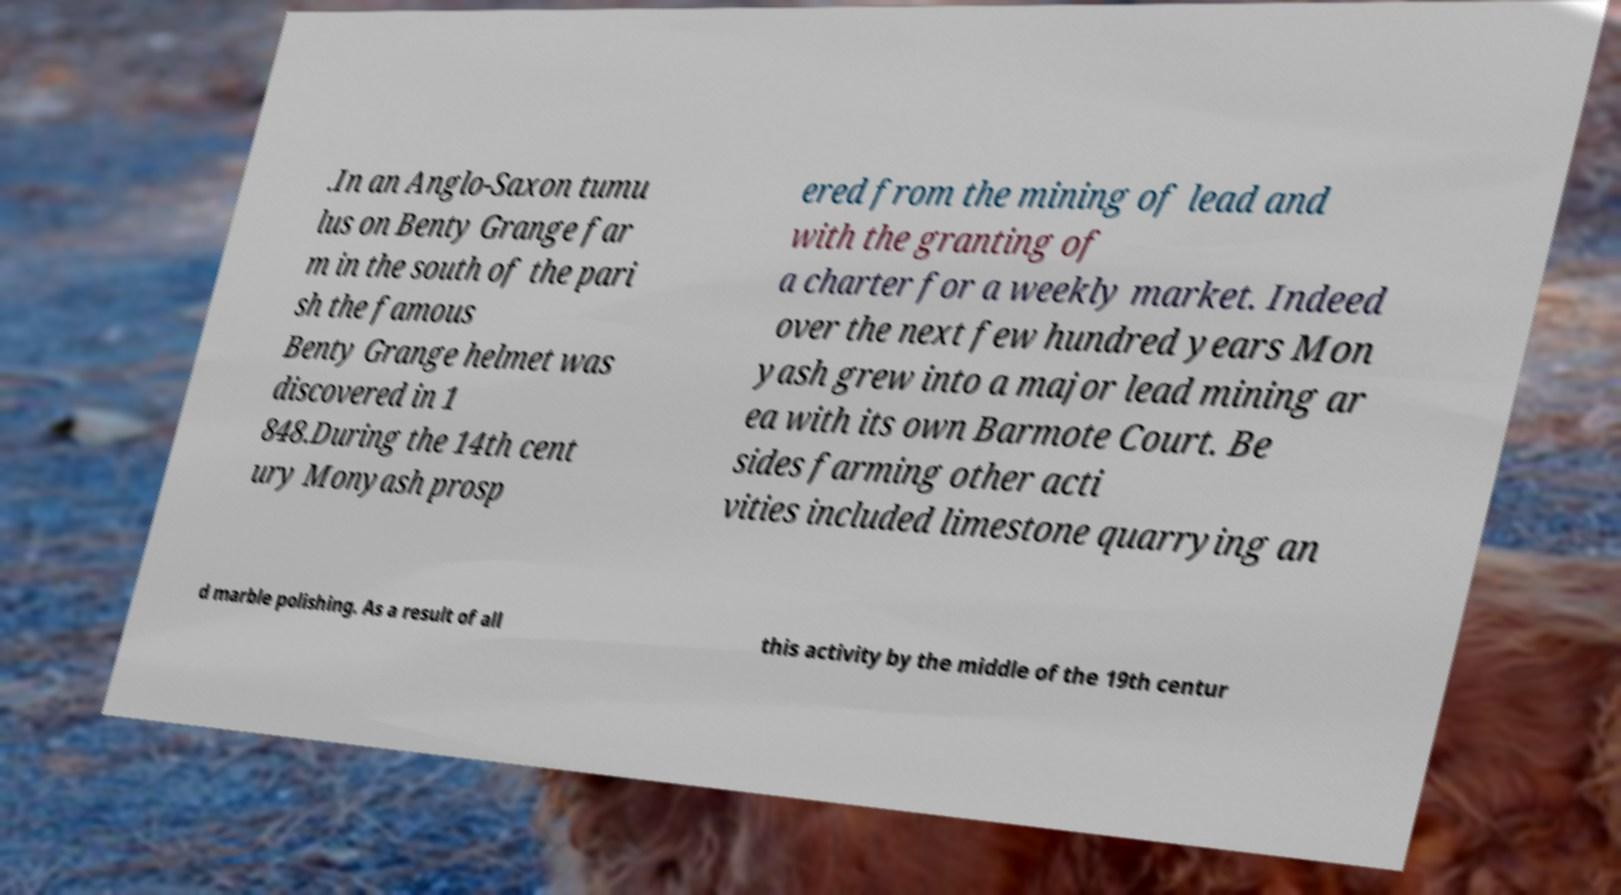For documentation purposes, I need the text within this image transcribed. Could you provide that? .In an Anglo-Saxon tumu lus on Benty Grange far m in the south of the pari sh the famous Benty Grange helmet was discovered in 1 848.During the 14th cent ury Monyash prosp ered from the mining of lead and with the granting of a charter for a weekly market. Indeed over the next few hundred years Mon yash grew into a major lead mining ar ea with its own Barmote Court. Be sides farming other acti vities included limestone quarrying an d marble polishing. As a result of all this activity by the middle of the 19th centur 